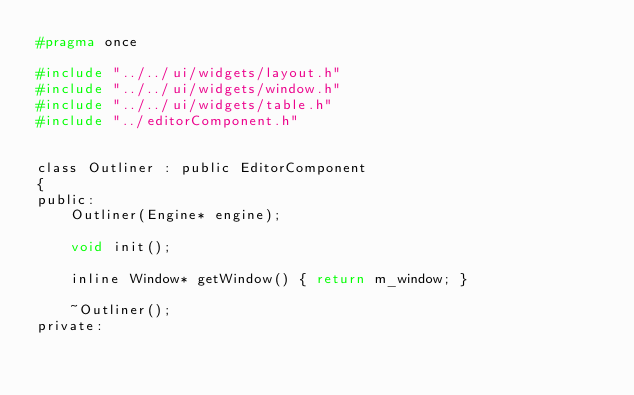Convert code to text. <code><loc_0><loc_0><loc_500><loc_500><_C_>#pragma once

#include "../../ui/widgets/layout.h"
#include "../../ui/widgets/window.h"
#include "../../ui/widgets/table.h"
#include "../editorComponent.h"


class Outliner : public EditorComponent
{
public:
	Outliner(Engine* engine);

	void init();

	inline Window* getWindow() { return m_window; }

	~Outliner();
private:</code> 